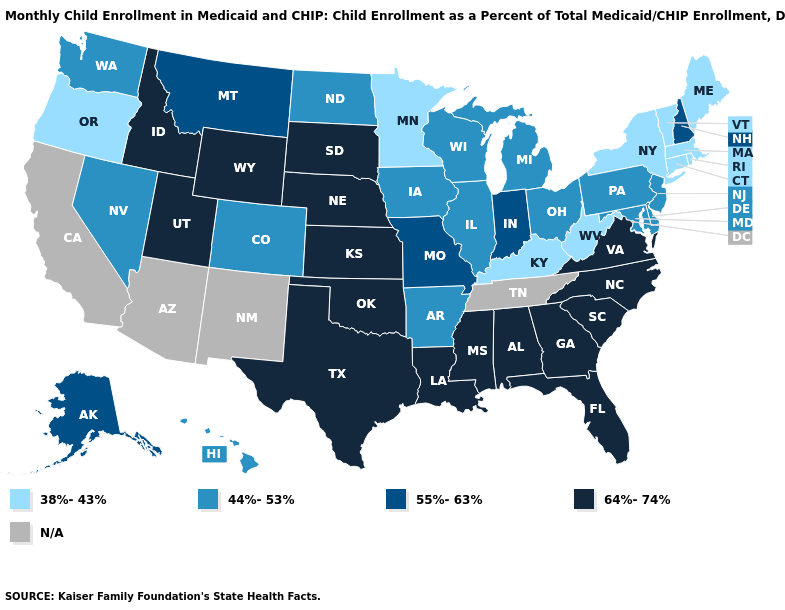What is the highest value in states that border Oregon?
Answer briefly. 64%-74%. Among the states that border Virginia , does North Carolina have the highest value?
Give a very brief answer. Yes. Name the states that have a value in the range 55%-63%?
Keep it brief. Alaska, Indiana, Missouri, Montana, New Hampshire. What is the value of New Jersey?
Give a very brief answer. 44%-53%. What is the lowest value in the MidWest?
Answer briefly. 38%-43%. What is the lowest value in the West?
Answer briefly. 38%-43%. What is the value of Pennsylvania?
Answer briefly. 44%-53%. Which states have the highest value in the USA?
Quick response, please. Alabama, Florida, Georgia, Idaho, Kansas, Louisiana, Mississippi, Nebraska, North Carolina, Oklahoma, South Carolina, South Dakota, Texas, Utah, Virginia, Wyoming. Does the map have missing data?
Keep it brief. Yes. What is the value of Delaware?
Answer briefly. 44%-53%. Does Minnesota have the lowest value in the USA?
Be succinct. Yes. What is the value of Minnesota?
Short answer required. 38%-43%. What is the value of Missouri?
Quick response, please. 55%-63%. Among the states that border Florida , which have the lowest value?
Write a very short answer. Alabama, Georgia. 